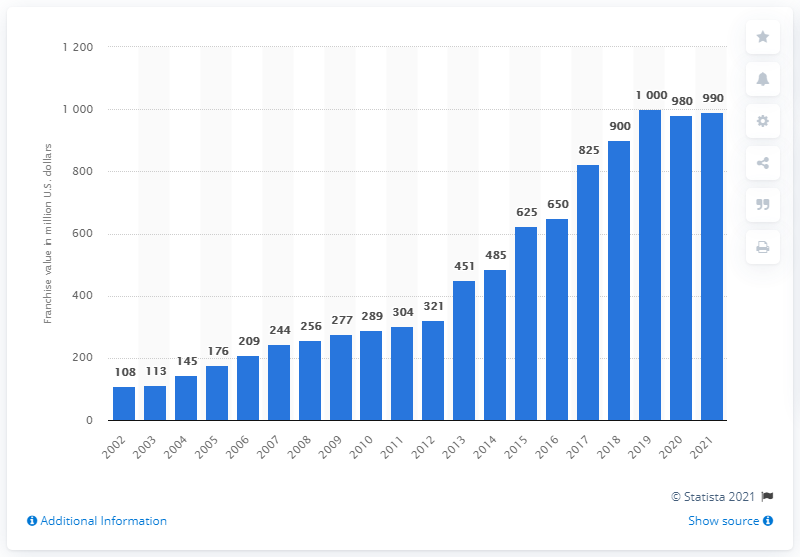Outline some significant characteristics in this image. In 2021, the estimated value of the Miami Marlins was approximately $990 million dollars. 